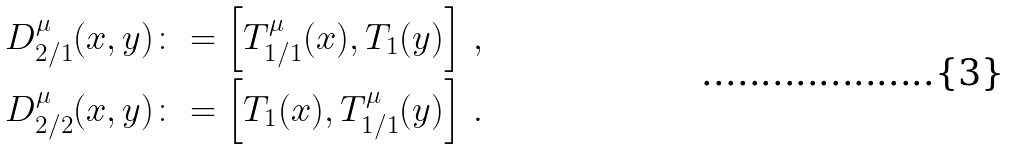<formula> <loc_0><loc_0><loc_500><loc_500>D _ { 2 / 1 } ^ { \mu } ( x , y ) & \colon = \left [ T _ { 1 / 1 } ^ { \mu } ( x ) , T _ { 1 } ( y ) \right ] \, , \\ D _ { 2 / 2 } ^ { \mu } ( x , y ) & \colon = \left [ T _ { 1 } ( x ) , T ^ { \mu } _ { 1 / 1 } ( y ) \right ] \, .</formula> 